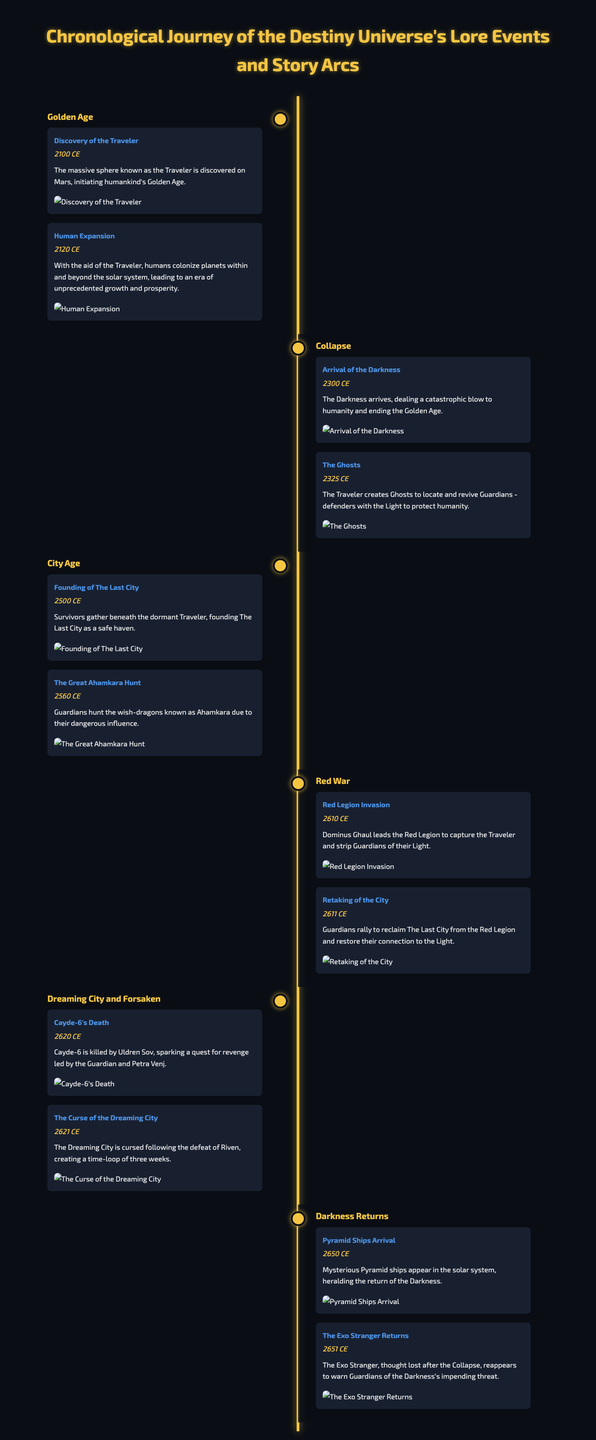What year was the Traveler discovered? The Traveler was discovered in the year stated as 2100 CE in the document.
Answer: 2100 CE Who leads the Red Legion? The text specifies that Dominus Ghaul leads the Red Legion during the event described.
Answer: Dominus Ghaul What significant event happened in 2621 CE? The document mentions that The Curse of the Dreaming City occurred in 2621 CE, which is a notable event.
Answer: The Curse of the Dreaming City What is the title of the era that includes Cayde-6's death? The title "Dreaming City and Forsaken" includes the event of Cayde-6's death as part of this specific era.
Answer: Dreaming City and Forsaken How many years passed between the arrival of the Darkness and the founding of The Last City? By calculating the years between 2300 CE (arrival of the Darkness) and 2500 CE (founding of The Last City), we find there are 200 years.
Answer: 200 years What significant object creates Ghosts for Guardians? The document states that the Traveler creates Ghosts, which are essential for reviving Guardians.
Answer: The Traveler In what year did the Pyramid Ships arrive? The document identifies the arrival of the Pyramid Ships in the year 2650 CE as a critical event.
Answer: 2650 CE What type of event is the Great Ahamkara Hunt categorized as? According to the timeline, the Great Ahamkara Hunt is categorized as an event significant to the City Age era.
Answer: Event in City Age 